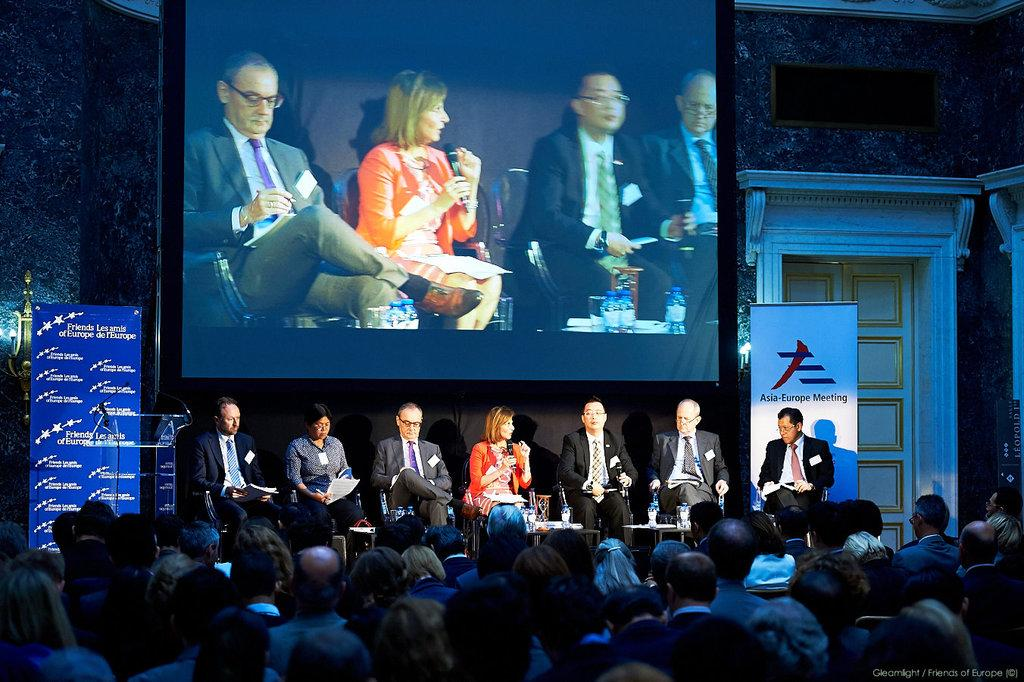What are the people in the image doing? There is a group of people sitting in the image. What can be seen hanging in the image? There are banners in the image. What is the large, flat surface used for in the image? There is a projector screen in the image, which is likely used for displaying visuals. What architectural feature is present in the image? There is a wall with a door in the image. What color is the door in the image? The door is white in color. Can you hear the ghost in the image? There is no ghost present in the image, so it is not possible to hear one. What sense is being used to perceive the visuals on the projector screen? The sense of sight is being used to perceive the visuals on the projector screen. 